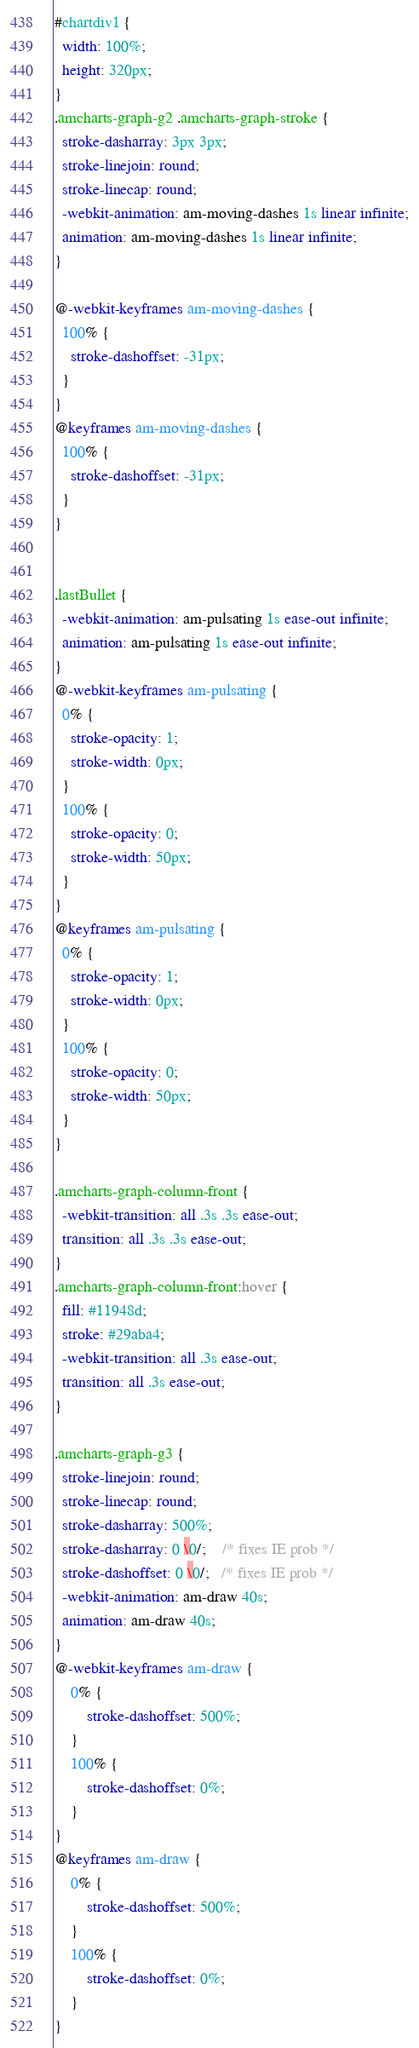<code> <loc_0><loc_0><loc_500><loc_500><_CSS_>#chartdiv1 {
  width: 100%;
  height: 320px;
}
.amcharts-graph-g2 .amcharts-graph-stroke {
  stroke-dasharray: 3px 3px;
  stroke-linejoin: round;
  stroke-linecap: round;
  -webkit-animation: am-moving-dashes 1s linear infinite;
  animation: am-moving-dashes 1s linear infinite;
}

@-webkit-keyframes am-moving-dashes {
  100% {
    stroke-dashoffset: -31px;
  }
}
@keyframes am-moving-dashes {
  100% {
    stroke-dashoffset: -31px;
  }
}


.lastBullet {
  -webkit-animation: am-pulsating 1s ease-out infinite;
  animation: am-pulsating 1s ease-out infinite;
}
@-webkit-keyframes am-pulsating {
  0% {
    stroke-opacity: 1;
    stroke-width: 0px;
  }
  100% {
    stroke-opacity: 0;
    stroke-width: 50px;
  }
}
@keyframes am-pulsating {
  0% {
    stroke-opacity: 1;
    stroke-width: 0px;
  }
  100% {
    stroke-opacity: 0;
    stroke-width: 50px;
  }
}

.amcharts-graph-column-front {
  -webkit-transition: all .3s .3s ease-out;
  transition: all .3s .3s ease-out;
}
.amcharts-graph-column-front:hover {
  fill: #11948d;
  stroke: #29aba4;
  -webkit-transition: all .3s ease-out;
  transition: all .3s ease-out;
}

.amcharts-graph-g3 {
  stroke-linejoin: round;
  stroke-linecap: round;
  stroke-dasharray: 500%;
  stroke-dasharray: 0 \0/;    /* fixes IE prob */
  stroke-dashoffset: 0 \0/;   /* fixes IE prob */
  -webkit-animation: am-draw 40s;
  animation: am-draw 40s;
}
@-webkit-keyframes am-draw {
    0% {
        stroke-dashoffset: 500%;
    }
    100% {
        stroke-dashoffset: 0%;
    }
}
@keyframes am-draw {
    0% {
        stroke-dashoffset: 500%;
    }
    100% {
        stroke-dashoffset: 0%;
    }
}</code> 